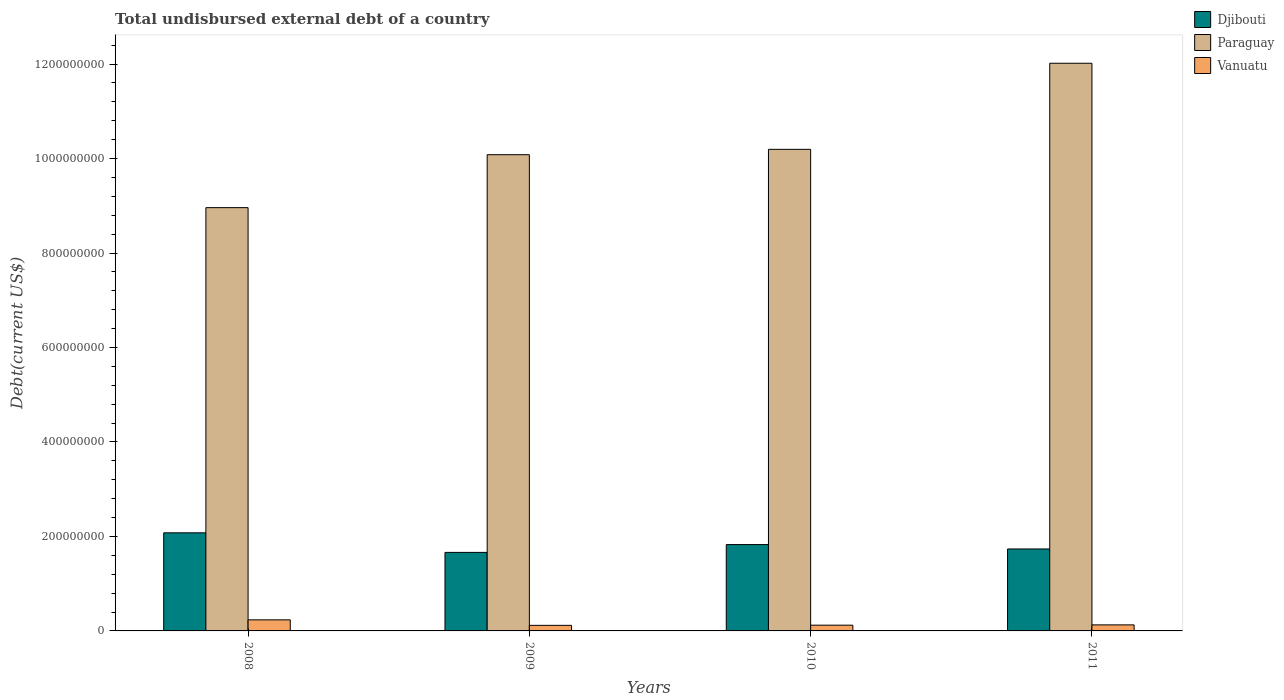How many different coloured bars are there?
Make the answer very short. 3. How many groups of bars are there?
Keep it short and to the point. 4. Are the number of bars per tick equal to the number of legend labels?
Make the answer very short. Yes. Are the number of bars on each tick of the X-axis equal?
Provide a succinct answer. Yes. How many bars are there on the 1st tick from the left?
Ensure brevity in your answer.  3. How many bars are there on the 1st tick from the right?
Your response must be concise. 3. In how many cases, is the number of bars for a given year not equal to the number of legend labels?
Provide a succinct answer. 0. What is the total undisbursed external debt in Paraguay in 2009?
Make the answer very short. 1.01e+09. Across all years, what is the maximum total undisbursed external debt in Djibouti?
Offer a terse response. 2.08e+08. Across all years, what is the minimum total undisbursed external debt in Djibouti?
Keep it short and to the point. 1.66e+08. In which year was the total undisbursed external debt in Djibouti maximum?
Your answer should be very brief. 2008. In which year was the total undisbursed external debt in Paraguay minimum?
Provide a succinct answer. 2008. What is the total total undisbursed external debt in Vanuatu in the graph?
Offer a terse response. 6.02e+07. What is the difference between the total undisbursed external debt in Djibouti in 2008 and that in 2010?
Your answer should be compact. 2.49e+07. What is the difference between the total undisbursed external debt in Vanuatu in 2011 and the total undisbursed external debt in Djibouti in 2008?
Provide a succinct answer. -1.95e+08. What is the average total undisbursed external debt in Djibouti per year?
Give a very brief answer. 1.83e+08. In the year 2008, what is the difference between the total undisbursed external debt in Vanuatu and total undisbursed external debt in Paraguay?
Ensure brevity in your answer.  -8.73e+08. What is the ratio of the total undisbursed external debt in Vanuatu in 2008 to that in 2010?
Keep it short and to the point. 1.93. Is the total undisbursed external debt in Paraguay in 2009 less than that in 2011?
Make the answer very short. Yes. What is the difference between the highest and the second highest total undisbursed external debt in Vanuatu?
Offer a very short reply. 1.07e+07. What is the difference between the highest and the lowest total undisbursed external debt in Vanuatu?
Provide a short and direct response. 1.16e+07. Is the sum of the total undisbursed external debt in Paraguay in 2010 and 2011 greater than the maximum total undisbursed external debt in Vanuatu across all years?
Keep it short and to the point. Yes. What does the 3rd bar from the left in 2008 represents?
Offer a very short reply. Vanuatu. What does the 2nd bar from the right in 2010 represents?
Offer a very short reply. Paraguay. Is it the case that in every year, the sum of the total undisbursed external debt in Paraguay and total undisbursed external debt in Djibouti is greater than the total undisbursed external debt in Vanuatu?
Ensure brevity in your answer.  Yes. How many years are there in the graph?
Offer a very short reply. 4. Does the graph contain grids?
Your answer should be compact. No. What is the title of the graph?
Provide a succinct answer. Total undisbursed external debt of a country. Does "Puerto Rico" appear as one of the legend labels in the graph?
Offer a very short reply. No. What is the label or title of the X-axis?
Provide a succinct answer. Years. What is the label or title of the Y-axis?
Offer a terse response. Debt(current US$). What is the Debt(current US$) of Djibouti in 2008?
Your response must be concise. 2.08e+08. What is the Debt(current US$) of Paraguay in 2008?
Provide a succinct answer. 8.96e+08. What is the Debt(current US$) of Vanuatu in 2008?
Offer a very short reply. 2.34e+07. What is the Debt(current US$) of Djibouti in 2009?
Offer a very short reply. 1.66e+08. What is the Debt(current US$) in Paraguay in 2009?
Your response must be concise. 1.01e+09. What is the Debt(current US$) of Vanuatu in 2009?
Give a very brief answer. 1.18e+07. What is the Debt(current US$) of Djibouti in 2010?
Provide a succinct answer. 1.83e+08. What is the Debt(current US$) in Paraguay in 2010?
Keep it short and to the point. 1.02e+09. What is the Debt(current US$) in Vanuatu in 2010?
Your response must be concise. 1.22e+07. What is the Debt(current US$) in Djibouti in 2011?
Provide a short and direct response. 1.73e+08. What is the Debt(current US$) in Paraguay in 2011?
Offer a terse response. 1.20e+09. What is the Debt(current US$) of Vanuatu in 2011?
Your answer should be compact. 1.28e+07. Across all years, what is the maximum Debt(current US$) in Djibouti?
Make the answer very short. 2.08e+08. Across all years, what is the maximum Debt(current US$) in Paraguay?
Make the answer very short. 1.20e+09. Across all years, what is the maximum Debt(current US$) in Vanuatu?
Your answer should be compact. 2.34e+07. Across all years, what is the minimum Debt(current US$) in Djibouti?
Ensure brevity in your answer.  1.66e+08. Across all years, what is the minimum Debt(current US$) of Paraguay?
Provide a succinct answer. 8.96e+08. Across all years, what is the minimum Debt(current US$) of Vanuatu?
Your answer should be very brief. 1.18e+07. What is the total Debt(current US$) in Djibouti in the graph?
Your answer should be very brief. 7.30e+08. What is the total Debt(current US$) in Paraguay in the graph?
Give a very brief answer. 4.13e+09. What is the total Debt(current US$) in Vanuatu in the graph?
Your answer should be compact. 6.02e+07. What is the difference between the Debt(current US$) of Djibouti in 2008 and that in 2009?
Offer a very short reply. 4.14e+07. What is the difference between the Debt(current US$) of Paraguay in 2008 and that in 2009?
Make the answer very short. -1.12e+08. What is the difference between the Debt(current US$) of Vanuatu in 2008 and that in 2009?
Offer a terse response. 1.16e+07. What is the difference between the Debt(current US$) in Djibouti in 2008 and that in 2010?
Provide a succinct answer. 2.49e+07. What is the difference between the Debt(current US$) of Paraguay in 2008 and that in 2010?
Give a very brief answer. -1.23e+08. What is the difference between the Debt(current US$) in Vanuatu in 2008 and that in 2010?
Offer a very short reply. 1.13e+07. What is the difference between the Debt(current US$) of Djibouti in 2008 and that in 2011?
Provide a succinct answer. 3.42e+07. What is the difference between the Debt(current US$) of Paraguay in 2008 and that in 2011?
Offer a very short reply. -3.06e+08. What is the difference between the Debt(current US$) of Vanuatu in 2008 and that in 2011?
Offer a terse response. 1.07e+07. What is the difference between the Debt(current US$) in Djibouti in 2009 and that in 2010?
Provide a short and direct response. -1.66e+07. What is the difference between the Debt(current US$) of Paraguay in 2009 and that in 2010?
Offer a very short reply. -1.13e+07. What is the difference between the Debt(current US$) in Vanuatu in 2009 and that in 2010?
Your answer should be compact. -3.66e+05. What is the difference between the Debt(current US$) in Djibouti in 2009 and that in 2011?
Give a very brief answer. -7.25e+06. What is the difference between the Debt(current US$) in Paraguay in 2009 and that in 2011?
Your response must be concise. -1.94e+08. What is the difference between the Debt(current US$) in Vanuatu in 2009 and that in 2011?
Offer a very short reply. -9.88e+05. What is the difference between the Debt(current US$) in Djibouti in 2010 and that in 2011?
Make the answer very short. 9.31e+06. What is the difference between the Debt(current US$) of Paraguay in 2010 and that in 2011?
Keep it short and to the point. -1.82e+08. What is the difference between the Debt(current US$) in Vanuatu in 2010 and that in 2011?
Keep it short and to the point. -6.22e+05. What is the difference between the Debt(current US$) of Djibouti in 2008 and the Debt(current US$) of Paraguay in 2009?
Provide a short and direct response. -8.00e+08. What is the difference between the Debt(current US$) in Djibouti in 2008 and the Debt(current US$) in Vanuatu in 2009?
Offer a very short reply. 1.96e+08. What is the difference between the Debt(current US$) of Paraguay in 2008 and the Debt(current US$) of Vanuatu in 2009?
Ensure brevity in your answer.  8.84e+08. What is the difference between the Debt(current US$) of Djibouti in 2008 and the Debt(current US$) of Paraguay in 2010?
Ensure brevity in your answer.  -8.12e+08. What is the difference between the Debt(current US$) in Djibouti in 2008 and the Debt(current US$) in Vanuatu in 2010?
Ensure brevity in your answer.  1.96e+08. What is the difference between the Debt(current US$) of Paraguay in 2008 and the Debt(current US$) of Vanuatu in 2010?
Provide a succinct answer. 8.84e+08. What is the difference between the Debt(current US$) in Djibouti in 2008 and the Debt(current US$) in Paraguay in 2011?
Provide a short and direct response. -9.94e+08. What is the difference between the Debt(current US$) in Djibouti in 2008 and the Debt(current US$) in Vanuatu in 2011?
Your answer should be very brief. 1.95e+08. What is the difference between the Debt(current US$) in Paraguay in 2008 and the Debt(current US$) in Vanuatu in 2011?
Give a very brief answer. 8.83e+08. What is the difference between the Debt(current US$) in Djibouti in 2009 and the Debt(current US$) in Paraguay in 2010?
Your response must be concise. -8.53e+08. What is the difference between the Debt(current US$) in Djibouti in 2009 and the Debt(current US$) in Vanuatu in 2010?
Keep it short and to the point. 1.54e+08. What is the difference between the Debt(current US$) of Paraguay in 2009 and the Debt(current US$) of Vanuatu in 2010?
Provide a short and direct response. 9.96e+08. What is the difference between the Debt(current US$) of Djibouti in 2009 and the Debt(current US$) of Paraguay in 2011?
Your answer should be very brief. -1.04e+09. What is the difference between the Debt(current US$) in Djibouti in 2009 and the Debt(current US$) in Vanuatu in 2011?
Your answer should be compact. 1.53e+08. What is the difference between the Debt(current US$) in Paraguay in 2009 and the Debt(current US$) in Vanuatu in 2011?
Your answer should be compact. 9.95e+08. What is the difference between the Debt(current US$) in Djibouti in 2010 and the Debt(current US$) in Paraguay in 2011?
Offer a terse response. -1.02e+09. What is the difference between the Debt(current US$) of Djibouti in 2010 and the Debt(current US$) of Vanuatu in 2011?
Provide a short and direct response. 1.70e+08. What is the difference between the Debt(current US$) in Paraguay in 2010 and the Debt(current US$) in Vanuatu in 2011?
Offer a terse response. 1.01e+09. What is the average Debt(current US$) of Djibouti per year?
Offer a very short reply. 1.83e+08. What is the average Debt(current US$) in Paraguay per year?
Offer a terse response. 1.03e+09. What is the average Debt(current US$) in Vanuatu per year?
Give a very brief answer. 1.50e+07. In the year 2008, what is the difference between the Debt(current US$) in Djibouti and Debt(current US$) in Paraguay?
Keep it short and to the point. -6.88e+08. In the year 2008, what is the difference between the Debt(current US$) of Djibouti and Debt(current US$) of Vanuatu?
Keep it short and to the point. 1.84e+08. In the year 2008, what is the difference between the Debt(current US$) in Paraguay and Debt(current US$) in Vanuatu?
Provide a short and direct response. 8.73e+08. In the year 2009, what is the difference between the Debt(current US$) in Djibouti and Debt(current US$) in Paraguay?
Your answer should be compact. -8.42e+08. In the year 2009, what is the difference between the Debt(current US$) in Djibouti and Debt(current US$) in Vanuatu?
Provide a short and direct response. 1.54e+08. In the year 2009, what is the difference between the Debt(current US$) of Paraguay and Debt(current US$) of Vanuatu?
Provide a short and direct response. 9.96e+08. In the year 2010, what is the difference between the Debt(current US$) in Djibouti and Debt(current US$) in Paraguay?
Make the answer very short. -8.37e+08. In the year 2010, what is the difference between the Debt(current US$) of Djibouti and Debt(current US$) of Vanuatu?
Your answer should be compact. 1.71e+08. In the year 2010, what is the difference between the Debt(current US$) in Paraguay and Debt(current US$) in Vanuatu?
Your answer should be compact. 1.01e+09. In the year 2011, what is the difference between the Debt(current US$) in Djibouti and Debt(current US$) in Paraguay?
Ensure brevity in your answer.  -1.03e+09. In the year 2011, what is the difference between the Debt(current US$) of Djibouti and Debt(current US$) of Vanuatu?
Make the answer very short. 1.61e+08. In the year 2011, what is the difference between the Debt(current US$) in Paraguay and Debt(current US$) in Vanuatu?
Give a very brief answer. 1.19e+09. What is the ratio of the Debt(current US$) of Djibouti in 2008 to that in 2009?
Your response must be concise. 1.25. What is the ratio of the Debt(current US$) of Paraguay in 2008 to that in 2009?
Provide a short and direct response. 0.89. What is the ratio of the Debt(current US$) of Vanuatu in 2008 to that in 2009?
Make the answer very short. 1.99. What is the ratio of the Debt(current US$) of Djibouti in 2008 to that in 2010?
Offer a terse response. 1.14. What is the ratio of the Debt(current US$) in Paraguay in 2008 to that in 2010?
Give a very brief answer. 0.88. What is the ratio of the Debt(current US$) of Vanuatu in 2008 to that in 2010?
Ensure brevity in your answer.  1.93. What is the ratio of the Debt(current US$) of Djibouti in 2008 to that in 2011?
Provide a short and direct response. 1.2. What is the ratio of the Debt(current US$) in Paraguay in 2008 to that in 2011?
Give a very brief answer. 0.75. What is the ratio of the Debt(current US$) of Vanuatu in 2008 to that in 2011?
Provide a succinct answer. 1.83. What is the ratio of the Debt(current US$) in Djibouti in 2009 to that in 2010?
Ensure brevity in your answer.  0.91. What is the ratio of the Debt(current US$) in Paraguay in 2009 to that in 2010?
Provide a succinct answer. 0.99. What is the ratio of the Debt(current US$) of Vanuatu in 2009 to that in 2010?
Make the answer very short. 0.97. What is the ratio of the Debt(current US$) in Djibouti in 2009 to that in 2011?
Make the answer very short. 0.96. What is the ratio of the Debt(current US$) of Paraguay in 2009 to that in 2011?
Keep it short and to the point. 0.84. What is the ratio of the Debt(current US$) in Vanuatu in 2009 to that in 2011?
Keep it short and to the point. 0.92. What is the ratio of the Debt(current US$) of Djibouti in 2010 to that in 2011?
Your response must be concise. 1.05. What is the ratio of the Debt(current US$) of Paraguay in 2010 to that in 2011?
Your response must be concise. 0.85. What is the ratio of the Debt(current US$) in Vanuatu in 2010 to that in 2011?
Offer a terse response. 0.95. What is the difference between the highest and the second highest Debt(current US$) in Djibouti?
Your response must be concise. 2.49e+07. What is the difference between the highest and the second highest Debt(current US$) of Paraguay?
Your response must be concise. 1.82e+08. What is the difference between the highest and the second highest Debt(current US$) in Vanuatu?
Ensure brevity in your answer.  1.07e+07. What is the difference between the highest and the lowest Debt(current US$) of Djibouti?
Offer a terse response. 4.14e+07. What is the difference between the highest and the lowest Debt(current US$) of Paraguay?
Keep it short and to the point. 3.06e+08. What is the difference between the highest and the lowest Debt(current US$) in Vanuatu?
Ensure brevity in your answer.  1.16e+07. 